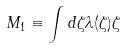Convert formula to latex. <formula><loc_0><loc_0><loc_500><loc_500>M _ { 1 } \equiv \int d \zeta \lambda ( \zeta ) \zeta</formula> 